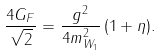Convert formula to latex. <formula><loc_0><loc_0><loc_500><loc_500>\frac { 4 G _ { F } } { \sqrt { 2 } } = \frac { g ^ { 2 } } { 4 m ^ { 2 } _ { W _ { 1 } } } \, ( 1 + \eta ) .</formula> 